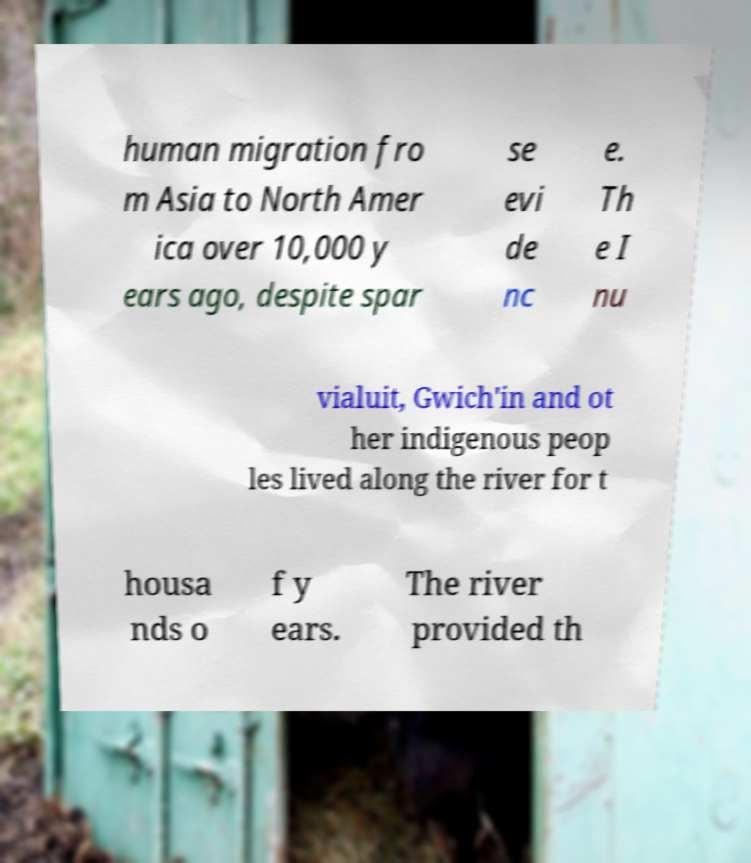Please identify and transcribe the text found in this image. human migration fro m Asia to North Amer ica over 10,000 y ears ago, despite spar se evi de nc e. Th e I nu vialuit, Gwich'in and ot her indigenous peop les lived along the river for t housa nds o f y ears. The river provided th 